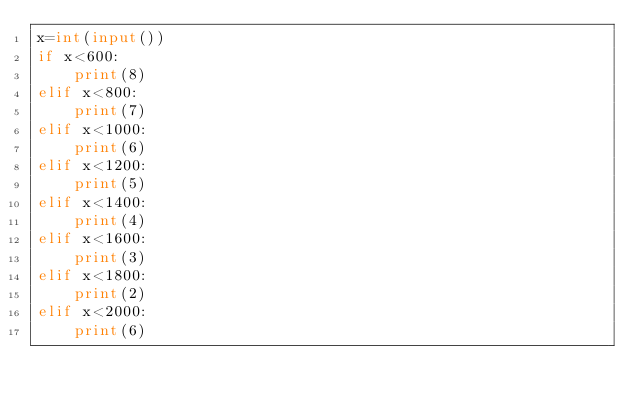<code> <loc_0><loc_0><loc_500><loc_500><_Python_>x=int(input())
if x<600:
    print(8)
elif x<800:
    print(7)
elif x<1000:
    print(6)
elif x<1200:
    print(5)
elif x<1400:
    print(4)
elif x<1600:
    print(3)
elif x<1800:
    print(2)
elif x<2000:
    print(6)</code> 